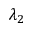Convert formula to latex. <formula><loc_0><loc_0><loc_500><loc_500>\lambda _ { 2 }</formula> 